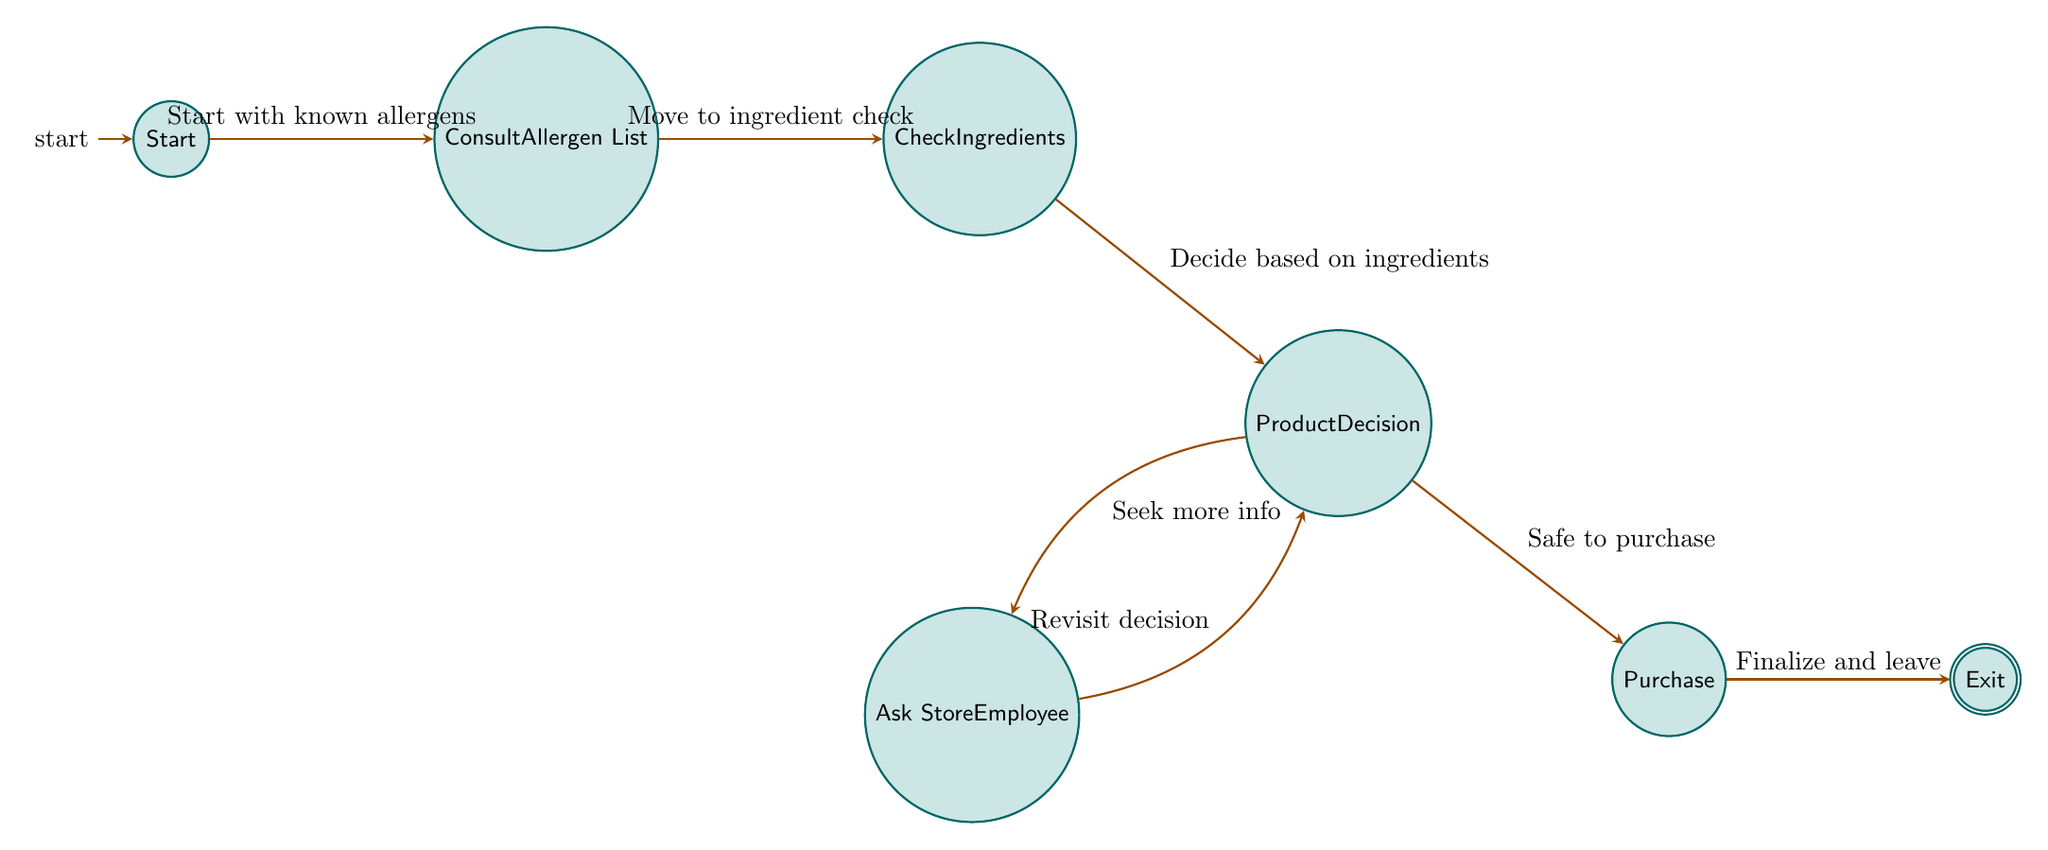What is the starting state of the diagram? The diagram begins with the "Start" state, which is the initial node indicating the commencement of the grocery shopping trip.
Answer: Start How many states are there in the diagram? The diagram consists of seven states, each representing a different step in the food allergy management process during grocery shopping.
Answer: Seven What is the last state before exiting the grocery store? The last state before exiting is "Purchase," where the decision is made to finalize the purchase of selected products.
Answer: Purchase What action leads from "Product Decision" to "Ask Store Employee"? The transition from "Product Decision" to "Ask Store Employee" occurs when the individual decides to seek more information if they are undecided about a product.
Answer: Seek more info How does one get from "Consult Allergen List" to "Check Ingredients"? One moves from "Consult Allergen List" to "Check Ingredients" after completing the consultation of the known allergens, signaling the next step to check specific product ingredients.
Answer: Move to ingredient check How many transitions are represented in the diagram? The diagram features six transitions, indicating the possible paths between states as the consumer navigates through the grocery shopping process while managing food allergies.
Answer: Six What is required to proceed from "Check Ingredients" to "Product Decision"? To proceed from "Check Ingredients" to "Product Decision," the user must evaluate the ingredient information gathered to make a purchasing choice based on allergen safety.
Answer: Decide based on ingredients If someone feels uncertain about a product, which node do they progress to? If someone feels uncertain, they progress to "Ask Store Employee" to obtain additional information regarding the product's allergen safety before making a final decision.
Answer: Ask Store Employee Which state is the accepting state in this diagram? The accepting state in the diagram is "Exit," indicating the completion of the grocery shopping process after the purchase of products.
Answer: Exit 